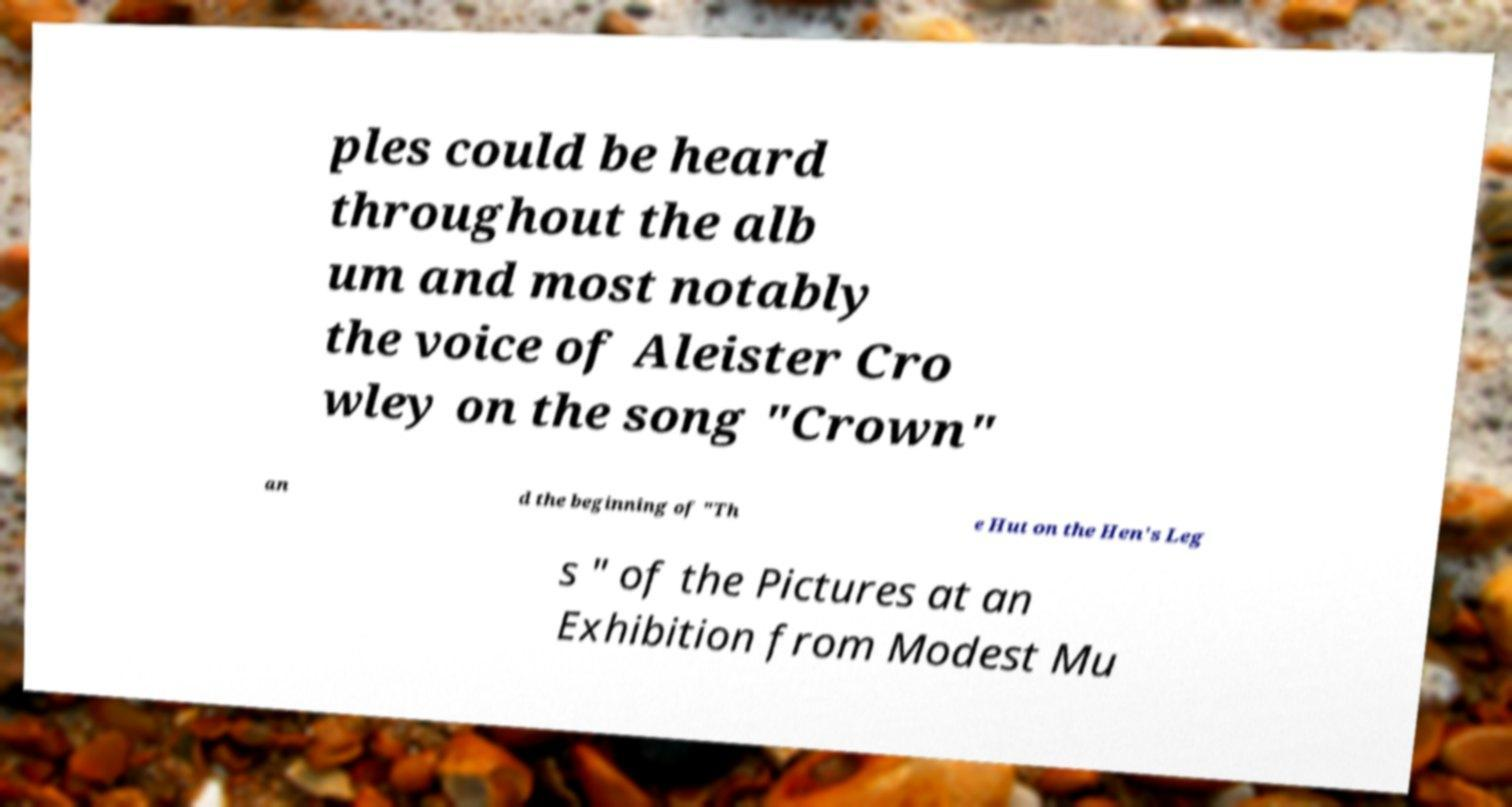For documentation purposes, I need the text within this image transcribed. Could you provide that? ples could be heard throughout the alb um and most notably the voice of Aleister Cro wley on the song "Crown" an d the beginning of "Th e Hut on the Hen's Leg s " of the Pictures at an Exhibition from Modest Mu 